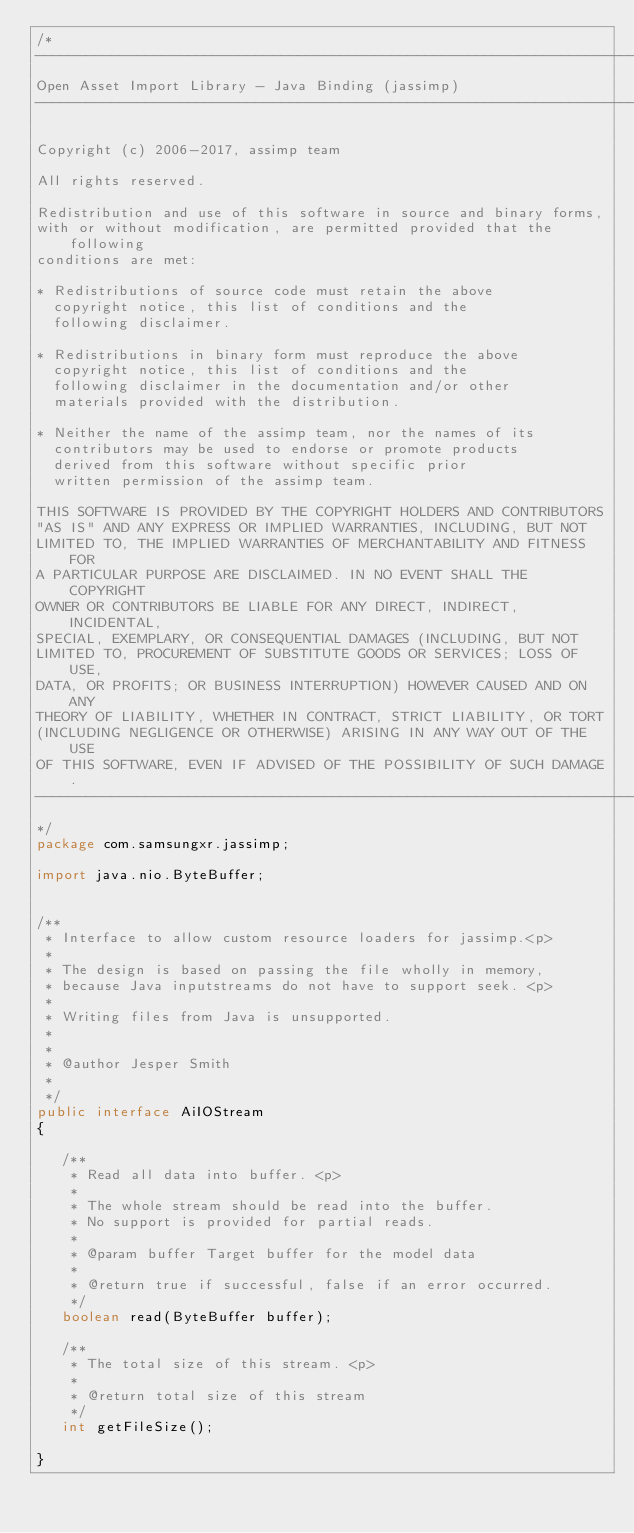Convert code to text. <code><loc_0><loc_0><loc_500><loc_500><_Java_>/*
---------------------------------------------------------------------------
Open Asset Import Library - Java Binding (jassimp)
---------------------------------------------------------------------------

Copyright (c) 2006-2017, assimp team

All rights reserved.

Redistribution and use of this software in source and binary forms, 
with or without modification, are permitted provided that the following 
conditions are met:

* Redistributions of source code must retain the above
  copyright notice, this list of conditions and the
  following disclaimer.

* Redistributions in binary form must reproduce the above
  copyright notice, this list of conditions and the
  following disclaimer in the documentation and/or other
  materials provided with the distribution.

* Neither the name of the assimp team, nor the names of its
  contributors may be used to endorse or promote products
  derived from this software without specific prior
  written permission of the assimp team.

THIS SOFTWARE IS PROVIDED BY THE COPYRIGHT HOLDERS AND CONTRIBUTORS 
"AS IS" AND ANY EXPRESS OR IMPLIED WARRANTIES, INCLUDING, BUT NOT 
LIMITED TO, THE IMPLIED WARRANTIES OF MERCHANTABILITY AND FITNESS FOR
A PARTICULAR PURPOSE ARE DISCLAIMED. IN NO EVENT SHALL THE COPYRIGHT 
OWNER OR CONTRIBUTORS BE LIABLE FOR ANY DIRECT, INDIRECT, INCIDENTAL,
SPECIAL, EXEMPLARY, OR CONSEQUENTIAL DAMAGES (INCLUDING, BUT NOT 
LIMITED TO, PROCUREMENT OF SUBSTITUTE GOODS OR SERVICES; LOSS OF USE,
DATA, OR PROFITS; OR BUSINESS INTERRUPTION) HOWEVER CAUSED AND ON ANY 
THEORY OF LIABILITY, WHETHER IN CONTRACT, STRICT LIABILITY, OR TORT 
(INCLUDING NEGLIGENCE OR OTHERWISE) ARISING IN ANY WAY OUT OF THE USE 
OF THIS SOFTWARE, EVEN IF ADVISED OF THE POSSIBILITY OF SUCH DAMAGE.
---------------------------------------------------------------------------
*/
package com.samsungxr.jassimp;

import java.nio.ByteBuffer;


/**
 * Interface to allow custom resource loaders for jassimp.<p>
 *
 * The design is based on passing the file wholly in memory, 
 * because Java inputstreams do not have to support seek. <p>
 * 
 * Writing files from Java is unsupported.
 * 
 * 
 * @author Jesper Smith
 *
 */
public interface AiIOStream
{

   /**
    * Read all data into buffer. <p>
    * 
    * The whole stream should be read into the buffer. 
    * No support is provided for partial reads. 
    * 
    * @param buffer Target buffer for the model data
    * 
    * @return true if successful, false if an error occurred.
    */
   boolean read(ByteBuffer buffer);

   /**
    * The total size of this stream. <p>
    *  
    * @return total size of this stream
    */
   int getFileSize();

}
</code> 